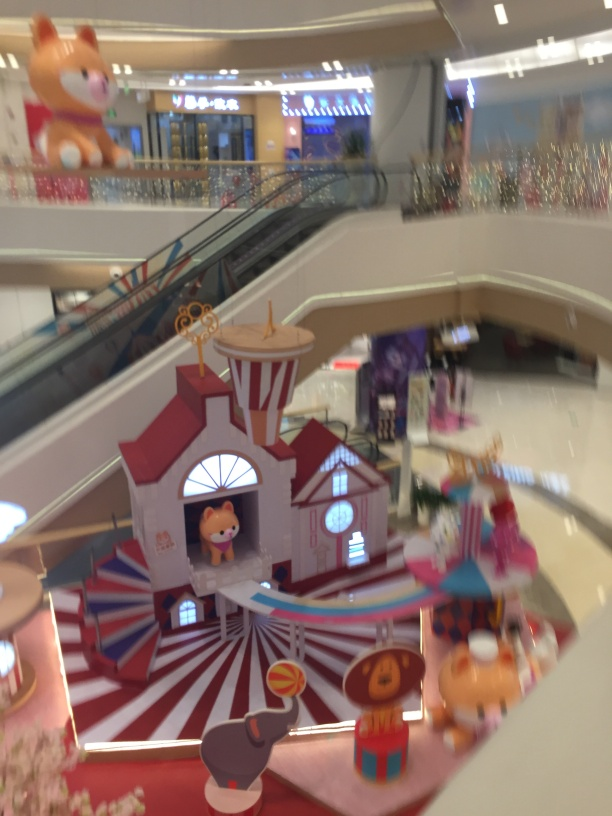What are some of the design elements visible in this image? The image features a variety of festive and eye-catching design elements including a circus tent-like structure with bold red and white stripes, colorful cartoon figures that could be mascots or play statues, and amusing props like oversized lollipops. There's also a mix of patterns and designs that contribute to a joyful and vibrant aesthetic. 